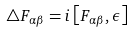<formula> <loc_0><loc_0><loc_500><loc_500>\bigtriangleup F _ { \alpha \beta } = i \left [ F _ { \alpha \beta } , \epsilon \right ]</formula> 